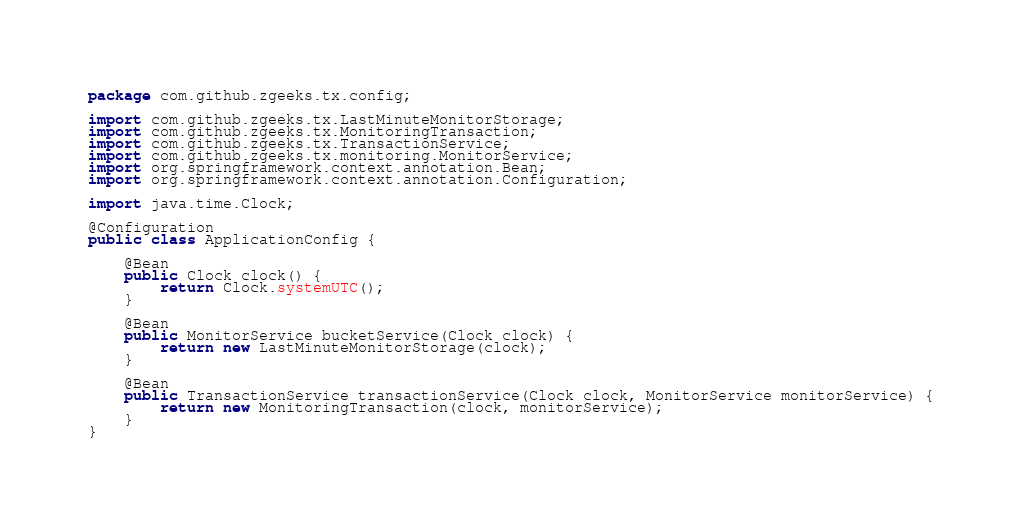<code> <loc_0><loc_0><loc_500><loc_500><_Java_>package com.github.zgeeks.tx.config;

import com.github.zgeeks.tx.LastMinuteMonitorStorage;
import com.github.zgeeks.tx.MonitoringTransaction;
import com.github.zgeeks.tx.TransactionService;
import com.github.zgeeks.tx.monitoring.MonitorService;
import org.springframework.context.annotation.Bean;
import org.springframework.context.annotation.Configuration;

import java.time.Clock;

@Configuration
public class ApplicationConfig {

    @Bean
    public Clock clock() {
        return Clock.systemUTC();
    }

    @Bean
    public MonitorService bucketService(Clock clock) {
        return new LastMinuteMonitorStorage(clock);
    }

    @Bean
    public TransactionService transactionService(Clock clock, MonitorService monitorService) {
        return new MonitoringTransaction(clock, monitorService);
    }
}
</code> 